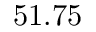Convert formula to latex. <formula><loc_0><loc_0><loc_500><loc_500>5 1 . 7 5</formula> 